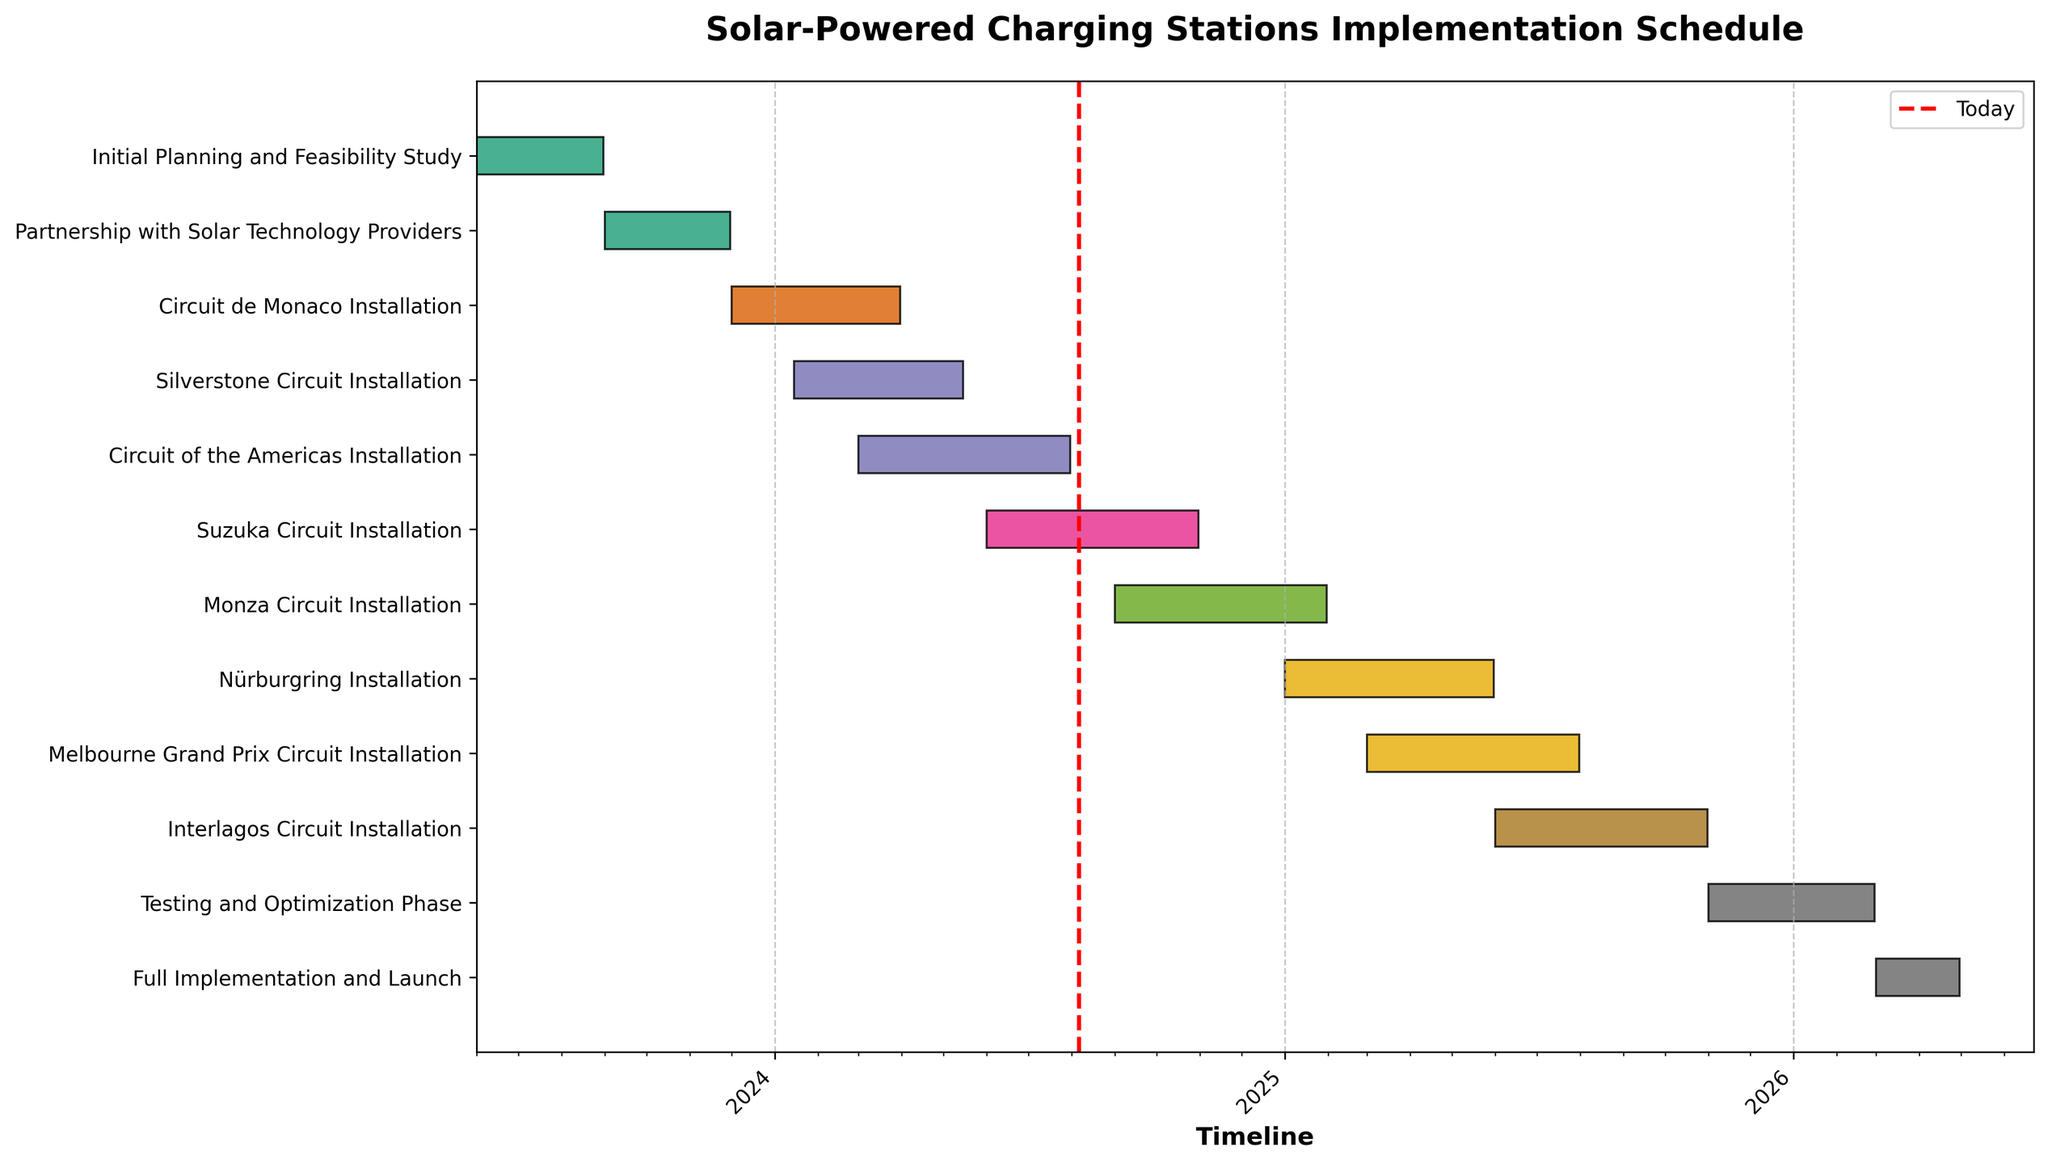Which task has the longest duration? The task duration is shown by the length of the bar in the Gantt Chart. By visually comparing the bars, the "Circuit of the Americas Installation" task has the longest duration from 2024-03-01 to 2024-07-31.
Answer: Circuit of the Americas Installation What is the current task in progress as of today? There is a vertical red line indicating today's date. By finding which bars overlap with this line, the current task in progress is "Partnership with Solar Technology Providers," which started on 2023-09-01 and will end on 2023-11-30.
Answer: Partnership with Solar Technology Providers How many tasks are scheduled to start in the year 2024? By looking at the tasks and their start dates on the timeline, we can see the tasks that begin in 2024: "Silverstone Circuit Installation" and "Circuit of the Americas Installation," "Suzuka Circuit Installation," and "Monza Circuit Installation."
Answer: 4 tasks Which circuit installation finishes first in the year 2024? Among the 2024 tasks, we check the end dates: "Circuit de Monaco Installation" ends on 2024-03-31, "Silverstone Circuit Installation" on 2024-05-15, "Circuit of the Americas Installation" on 2024-07-31, and "Suzuka Circuit Installation" on 2024-10-31. Therefore, the first to finish is "Circuit de Monaco Installation."
Answer: Circuit de Monaco Installation What is the total duration for all circuit installations combined? To find the total duration, sum all individual durations: 
- Circuit de Monaco: 122 days
- Silverstone Circuit: 121 days
- Circuit of the Americas: 153 days
- Suzuka Circuit: 153 days
- Monza Circuit: 153 days
- Nürburgring: 151 days
- Melbourne Grand Prix Circuit: 153 days
- Interlagos Circuit: 153 days
Sum: 122 + 121 + 153 + 153 + 153 + 151 + 153 + 153 = 1159 days.
Answer: 1159 days Which task starts last, before the testing and optimization phase? The "Testing and Optimization Phase" starts on 2025-11-01. The task that starts right before this can be found by examining the start dates: "Interlagos Circuit Installation" starts on 2025-06-01 and ends on 2025-10-31.
Answer: Interlagos Circuit Installation What is the average duration of the installation tasks for the circuits? Calculate the average duration of just the installation tasks (8 tasks):
(122 + 121 + 153 + 153 + 153 + 151 + 153 + 153) / 8 = 1159 / 8 = 144.875 days.
Answer: 144.875 days Which two installations have overlapping schedules? By closely examining the timeline, the overlapping schedules are:
- "Silverstone Circuit Installation" (2024-01-15 to 2024-05-15) and "Circuit of the Americas Installation" (2024-03-01 to 2024-07-31).
Answer: Silverstone Circuit Installation and Circuit of the Americas Installation When is the full implementation and launch scheduled to complete? According to the Gantt Chart, the "Full Implementation and Launch" task is scheduled from 2026-03-01 to 2026-04-30.
Answer: 2026-04-30 